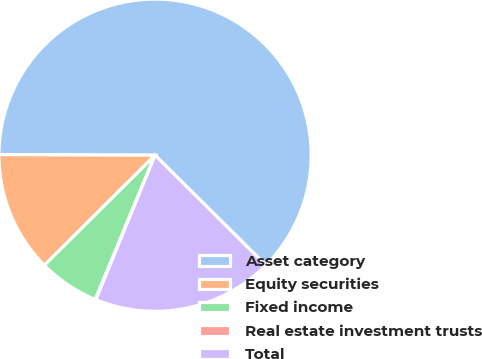Convert chart to OTSL. <chart><loc_0><loc_0><loc_500><loc_500><pie_chart><fcel>Asset category<fcel>Equity securities<fcel>Fixed income<fcel>Real estate investment trusts<fcel>Total<nl><fcel>62.37%<fcel>12.52%<fcel>6.29%<fcel>0.06%<fcel>18.75%<nl></chart> 